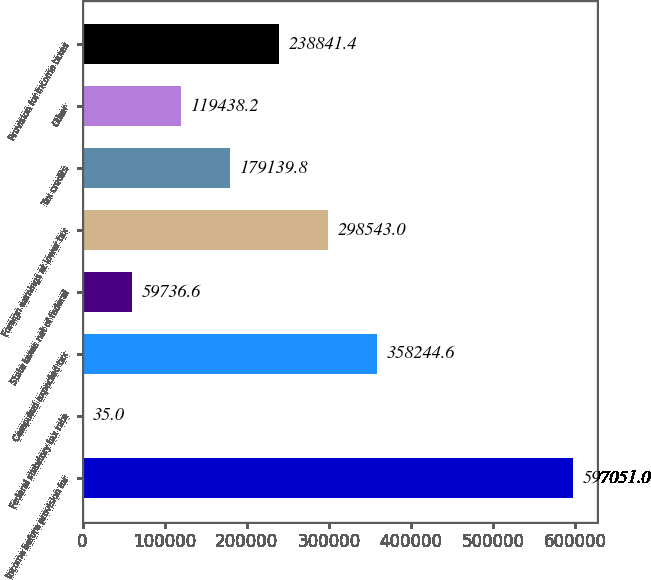<chart> <loc_0><loc_0><loc_500><loc_500><bar_chart><fcel>Income before provision for<fcel>Federal statutory tax rate<fcel>Computed expected tax<fcel>State taxes net of federal<fcel>Foreign earnings at lower tax<fcel>Tax credits<fcel>Other<fcel>Provision for income taxes<nl><fcel>597051<fcel>35<fcel>358245<fcel>59736.6<fcel>298543<fcel>179140<fcel>119438<fcel>238841<nl></chart> 